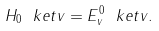<formula> <loc_0><loc_0><loc_500><loc_500>H _ { 0 } \ k e t { v } = E _ { v } ^ { 0 } \ k e t { v } .</formula> 